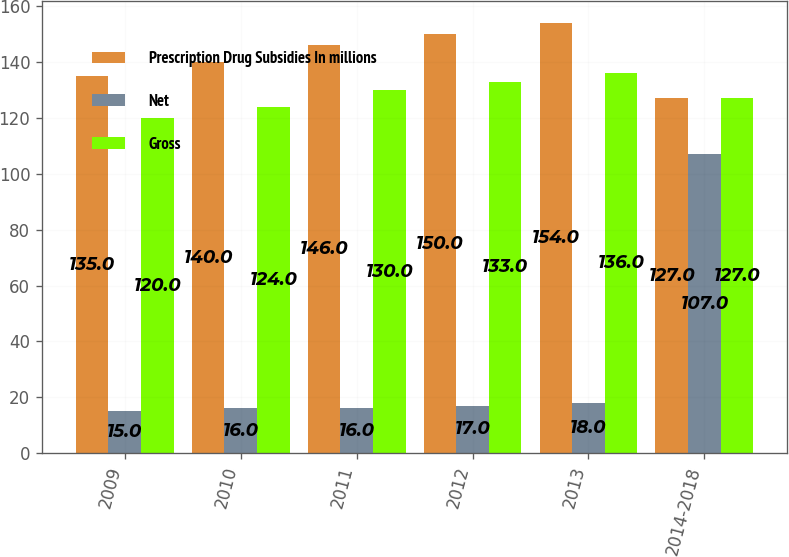<chart> <loc_0><loc_0><loc_500><loc_500><stacked_bar_chart><ecel><fcel>2009<fcel>2010<fcel>2011<fcel>2012<fcel>2013<fcel>2014-2018<nl><fcel>Prescription Drug Subsidies In millions<fcel>135<fcel>140<fcel>146<fcel>150<fcel>154<fcel>127<nl><fcel>Net<fcel>15<fcel>16<fcel>16<fcel>17<fcel>18<fcel>107<nl><fcel>Gross<fcel>120<fcel>124<fcel>130<fcel>133<fcel>136<fcel>127<nl></chart> 